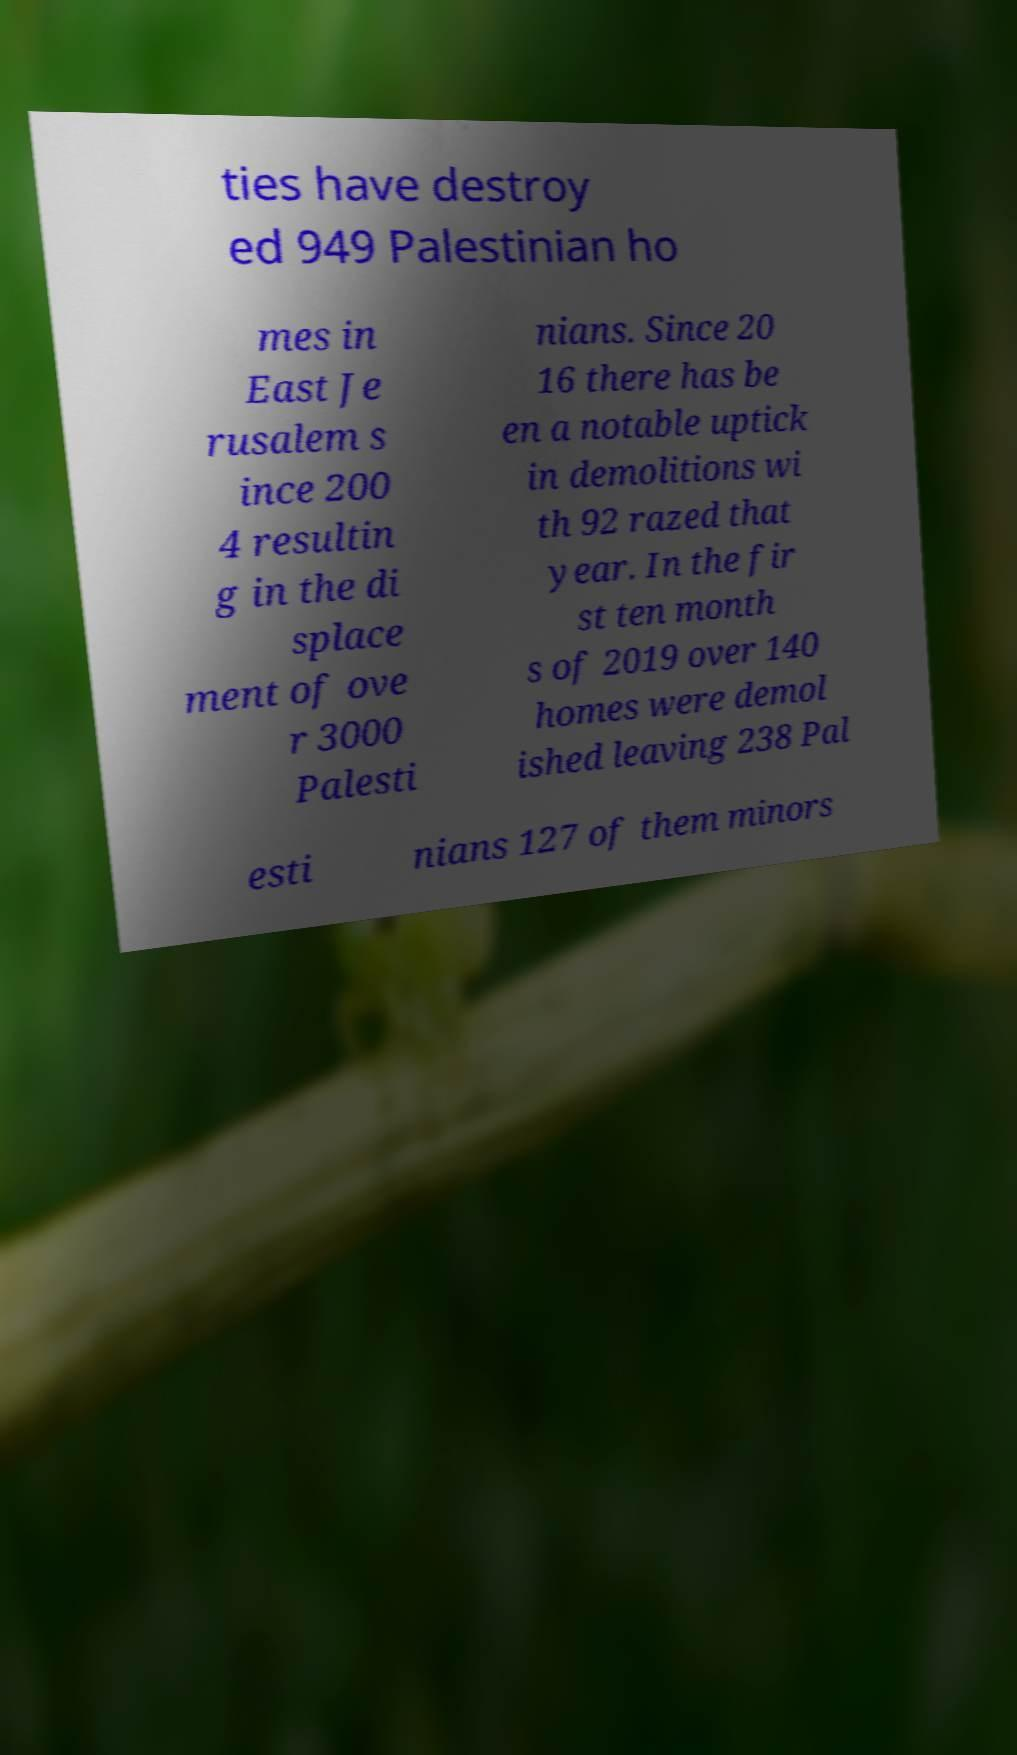There's text embedded in this image that I need extracted. Can you transcribe it verbatim? ties have destroy ed 949 Palestinian ho mes in East Je rusalem s ince 200 4 resultin g in the di splace ment of ove r 3000 Palesti nians. Since 20 16 there has be en a notable uptick in demolitions wi th 92 razed that year. In the fir st ten month s of 2019 over 140 homes were demol ished leaving 238 Pal esti nians 127 of them minors 